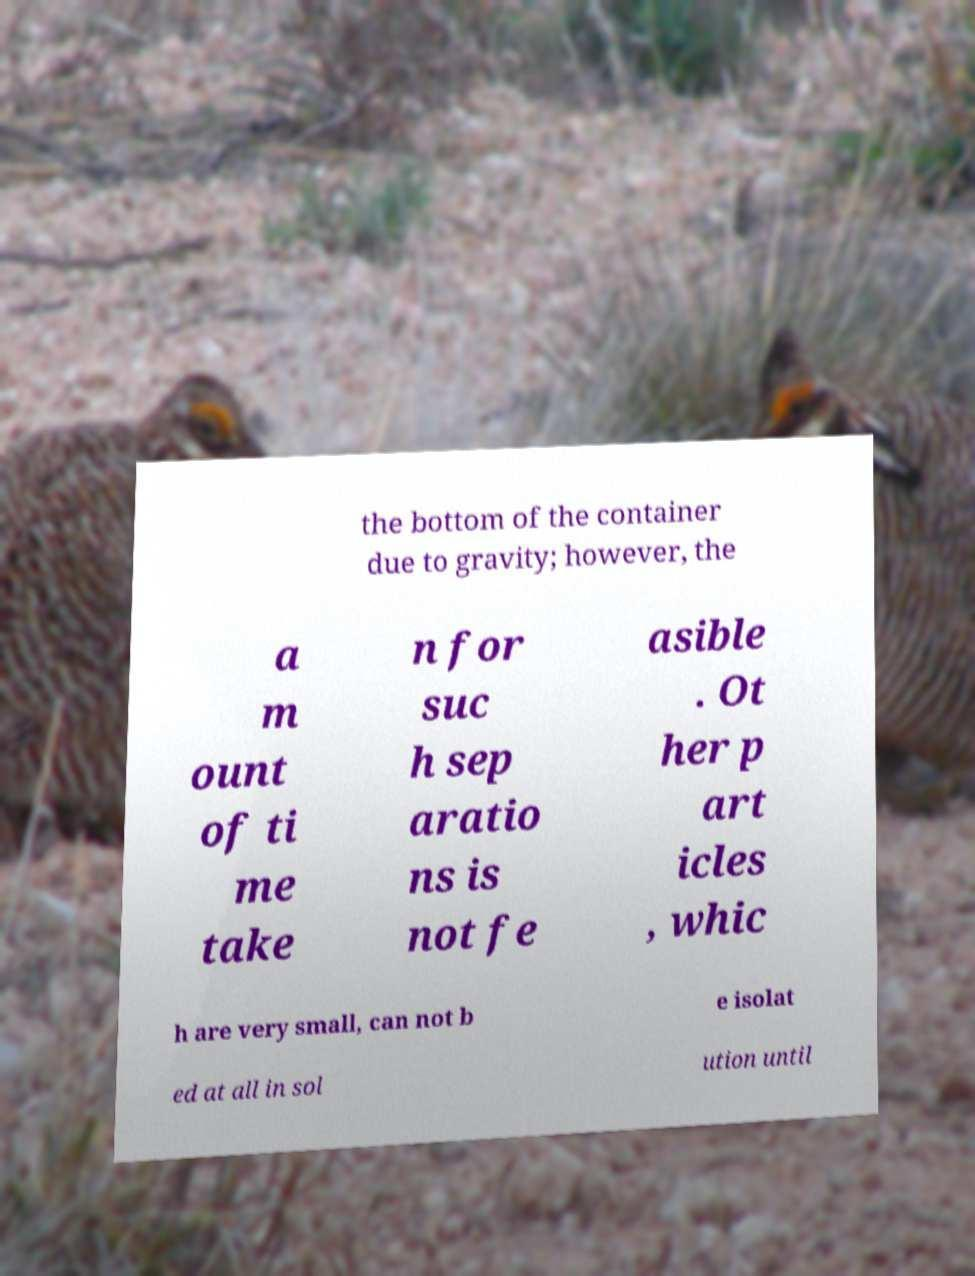I need the written content from this picture converted into text. Can you do that? the bottom of the container due to gravity; however, the a m ount of ti me take n for suc h sep aratio ns is not fe asible . Ot her p art icles , whic h are very small, can not b e isolat ed at all in sol ution until 